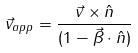Convert formula to latex. <formula><loc_0><loc_0><loc_500><loc_500>\vec { v } _ { a p p } = \frac { \vec { v } \times \hat { n } } { ( 1 - \vec { \beta } \cdot \hat { n } ) }</formula> 